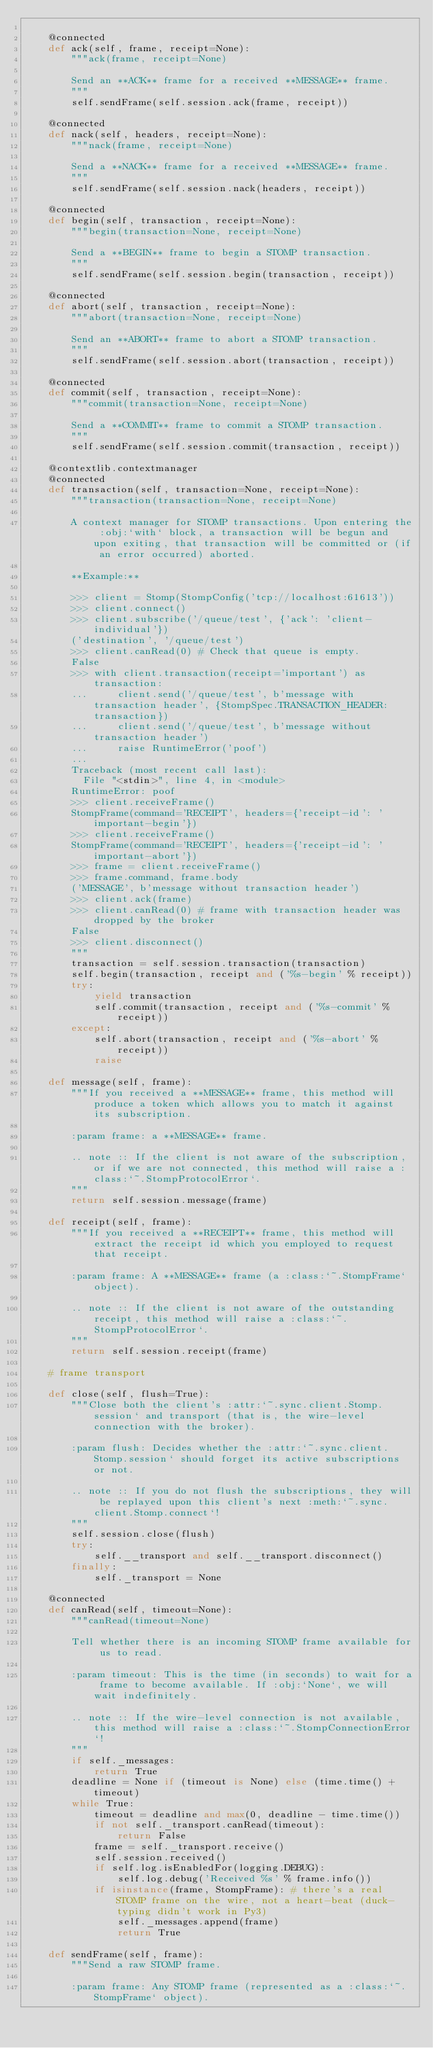Convert code to text. <code><loc_0><loc_0><loc_500><loc_500><_Python_>
    @connected
    def ack(self, frame, receipt=None):
        """ack(frame, receipt=None)
        
        Send an **ACK** frame for a received **MESSAGE** frame.
        """
        self.sendFrame(self.session.ack(frame, receipt))

    @connected
    def nack(self, headers, receipt=None):
        """nack(frame, receipt=None)
        
        Send a **NACK** frame for a received **MESSAGE** frame.
        """
        self.sendFrame(self.session.nack(headers, receipt))

    @connected
    def begin(self, transaction, receipt=None):
        """begin(transaction=None, receipt=None)
        
        Send a **BEGIN** frame to begin a STOMP transaction.
        """
        self.sendFrame(self.session.begin(transaction, receipt))

    @connected
    def abort(self, transaction, receipt=None):
        """abort(transaction=None, receipt=None)
        
        Send an **ABORT** frame to abort a STOMP transaction.
        """
        self.sendFrame(self.session.abort(transaction, receipt))

    @connected
    def commit(self, transaction, receipt=None):
        """commit(transaction=None, receipt=None)
        
        Send a **COMMIT** frame to commit a STOMP transaction.
        """
        self.sendFrame(self.session.commit(transaction, receipt))

    @contextlib.contextmanager
    @connected
    def transaction(self, transaction=None, receipt=None):
        """transaction(transaction=None, receipt=None)
        
        A context manager for STOMP transactions. Upon entering the :obj:`with` block, a transaction will be begun and upon exiting, that transaction will be committed or (if an error occurred) aborted.
        
        **Example:**
        
        >>> client = Stomp(StompConfig('tcp://localhost:61613'))
        >>> client.connect()
        >>> client.subscribe('/queue/test', {'ack': 'client-individual'})
        ('destination', '/queue/test')
        >>> client.canRead(0) # Check that queue is empty.
        False
        >>> with client.transaction(receipt='important') as transaction:
        ...     client.send('/queue/test', b'message with transaction header', {StompSpec.TRANSACTION_HEADER: transaction})
        ...     client.send('/queue/test', b'message without transaction header')
        ...     raise RuntimeError('poof')
        ... 
        Traceback (most recent call last):
          File "<stdin>", line 4, in <module>
        RuntimeError: poof
        >>> client.receiveFrame()
        StompFrame(command='RECEIPT', headers={'receipt-id': 'important-begin'})
        >>> client.receiveFrame()
        StompFrame(command='RECEIPT', headers={'receipt-id': 'important-abort'})
        >>> frame = client.receiveFrame()
        >>> frame.command, frame.body
        ('MESSAGE', b'message without transaction header')
        >>> client.ack(frame)
        >>> client.canRead(0) # frame with transaction header was dropped by the broker
        False
        >>> client.disconnect()
        """
        transaction = self.session.transaction(transaction)
        self.begin(transaction, receipt and ('%s-begin' % receipt))
        try:
            yield transaction
            self.commit(transaction, receipt and ('%s-commit' % receipt))
        except:
            self.abort(transaction, receipt and ('%s-abort' % receipt))
            raise

    def message(self, frame):
        """If you received a **MESSAGE** frame, this method will produce a token which allows you to match it against its subscription.
        
        :param frame: a **MESSAGE** frame.
        
        .. note :: If the client is not aware of the subscription, or if we are not connected, this method will raise a :class:`~.StompProtocolError`.
        """
        return self.session.message(frame)

    def receipt(self, frame):
        """If you received a **RECEIPT** frame, this method will extract the receipt id which you employed to request that receipt.
        
        :param frame: A **MESSAGE** frame (a :class:`~.StompFrame` object).
        
        .. note :: If the client is not aware of the outstanding receipt, this method will raise a :class:`~.StompProtocolError`.
        """
        return self.session.receipt(frame)

    # frame transport

    def close(self, flush=True):
        """Close both the client's :attr:`~.sync.client.Stomp.session` and transport (that is, the wire-level connection with the broker).
        
        :param flush: Decides whether the :attr:`~.sync.client.Stomp.session` should forget its active subscriptions or not.
        
        .. note :: If you do not flush the subscriptions, they will be replayed upon this client's next :meth:`~.sync.client.Stomp.connect`!
        """
        self.session.close(flush)
        try:
            self.__transport and self.__transport.disconnect()
        finally:
            self._transport = None

    @connected
    def canRead(self, timeout=None):
        """canRead(timeout=None)
        
        Tell whether there is an incoming STOMP frame available for us to read.

        :param timeout: This is the time (in seconds) to wait for a frame to become available. If :obj:`None`, we will wait indefinitely.
        
        .. note :: If the wire-level connection is not available, this method will raise a :class:`~.StompConnectionError`!
        """
        if self._messages:
            return True
        deadline = None if (timeout is None) else (time.time() + timeout)
        while True:
            timeout = deadline and max(0, deadline - time.time())
            if not self._transport.canRead(timeout):
                return False
            frame = self._transport.receive()
            self.session.received()
            if self.log.isEnabledFor(logging.DEBUG):
                self.log.debug('Received %s' % frame.info())
            if isinstance(frame, StompFrame): # there's a real STOMP frame on the wire, not a heart-beat (duck-typing didn't work in Py3)
                self._messages.append(frame)
                return True

    def sendFrame(self, frame):
        """Send a raw STOMP frame.
        
        :param frame: Any STOMP frame (represented as a :class:`~.StompFrame` object).
</code> 